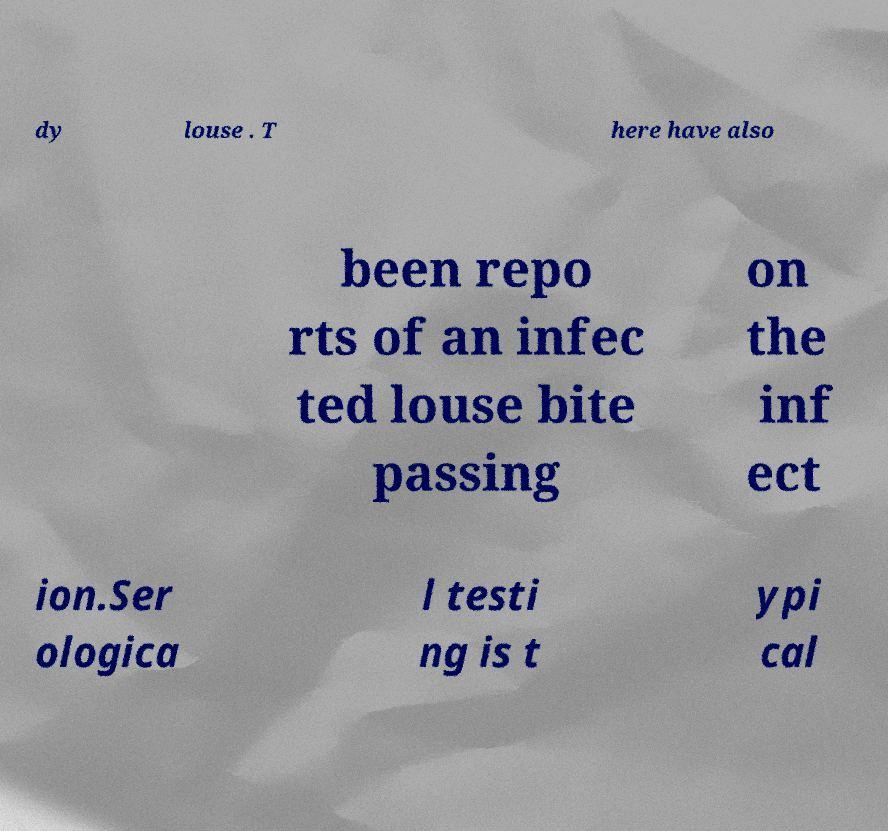Could you extract and type out the text from this image? dy louse . T here have also been repo rts of an infec ted louse bite passing on the inf ect ion.Ser ologica l testi ng is t ypi cal 